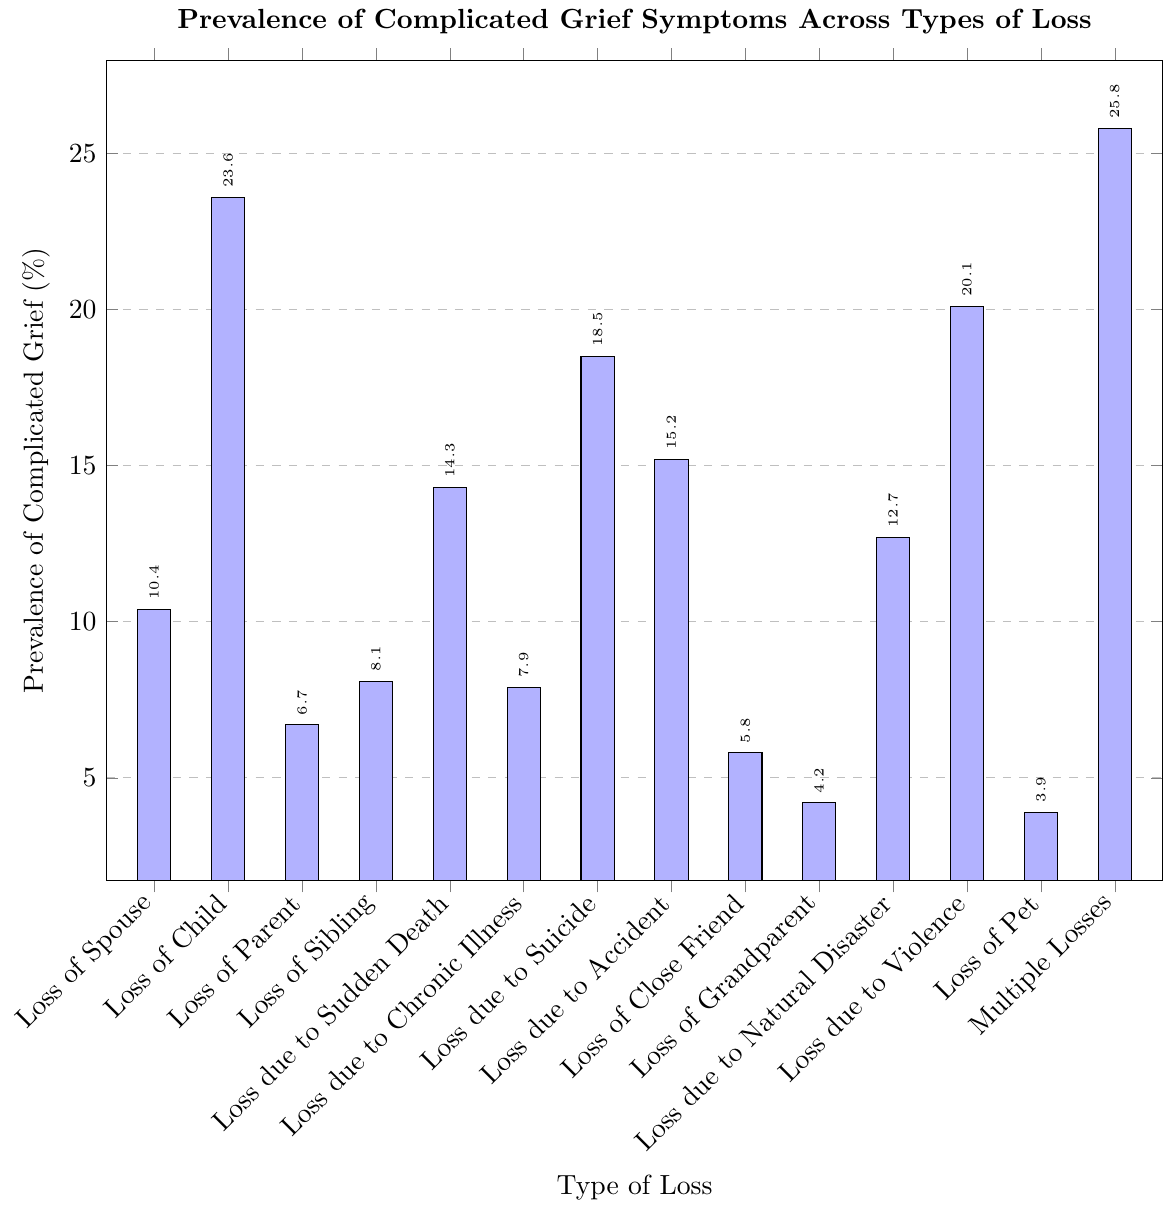What's the prevalence of complicated grief symptoms for the loss of a parent? Look for the bar labeled "Loss of Parent" in the figure. According to the y-axis, the height of the bar indicates 6.7%.
Answer: 6.7% Which type of loss has the highest prevalence of complicated grief symptoms? Compare the heights of all bars in the figure. The tallest bar corresponds to "Multiple Losses" with a prevalence of 25.8%.
Answer: Multiple Losses What is the combined prevalence of complicated grief symptoms for loss due to suicide and loss due to violence? First, find the prevalence for "Loss due to Suicide" (18.5%) and "Loss due to Violence" (20.1%). Add these values together: 18.5% + 20.1% = 38.6%.
Answer: 38.6% Is the prevalence of complicated grief symptoms higher for loss of a spouse or loss of a child? Compare the heights of the bars for "Loss of Spouse" and "Loss of Child". The prevalence for "Loss of Child" (23.6%) is higher than for "Loss of Spouse" (10.4%).
Answer: Loss of Child Which type of loss has the lowest prevalence of complicated grief symptoms? Identify the shortest bar in the figure, which corresponds to "Loss of Pet" with a prevalence of 3.9%.
Answer: Loss of Pet What is the average prevalence of complicated grief symptoms for losses directly involving immediate family members (Spouse, Child, Parent, Sibling)? Find the prevalences: Loss of Spouse (10.4%), Loss of Child (23.6%), Loss of Parent (6.7%), Loss of Sibling (8.1%). Compute the average: (10.4% + 23.6% + 6.7% + 8.1%) / 4 = 12.2%.
Answer: 12.2% Is the prevalence of complicated grief symptoms due to sudden death higher or lower than due to chronic illness? Compare the bars for "Loss due to Sudden Death" (14.3%) and "Loss due to Chronic Illness" (7.9%). The prevalence is higher for "Loss due to Sudden Death".
Answer: Higher What is the difference in prevalence of complicated grief symptoms between loss due to natural disaster and loss due to accident? Find the prevalence for "Loss due to Natural Disaster" (12.7%) and "Loss due to Accident" (15.2%). Calculate the difference: 15.2% - 12.7% = 2.5%.
Answer: 2.5% Which type of loss has a prevalence of complicated grief symptoms closest to 15%? Compare the prevalence values to 15%. "Loss due to Accident" has a prevalence of 15.2%, which is the closest to 15%.
Answer: Loss due to Accident 